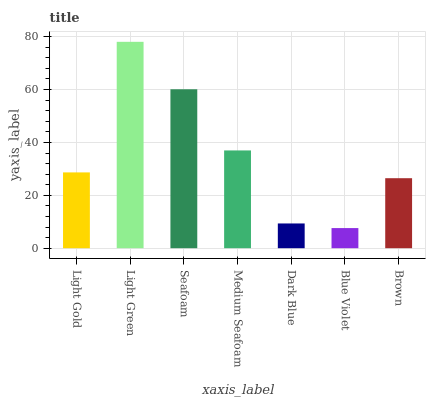Is Blue Violet the minimum?
Answer yes or no. Yes. Is Light Green the maximum?
Answer yes or no. Yes. Is Seafoam the minimum?
Answer yes or no. No. Is Seafoam the maximum?
Answer yes or no. No. Is Light Green greater than Seafoam?
Answer yes or no. Yes. Is Seafoam less than Light Green?
Answer yes or no. Yes. Is Seafoam greater than Light Green?
Answer yes or no. No. Is Light Green less than Seafoam?
Answer yes or no. No. Is Light Gold the high median?
Answer yes or no. Yes. Is Light Gold the low median?
Answer yes or no. Yes. Is Brown the high median?
Answer yes or no. No. Is Medium Seafoam the low median?
Answer yes or no. No. 